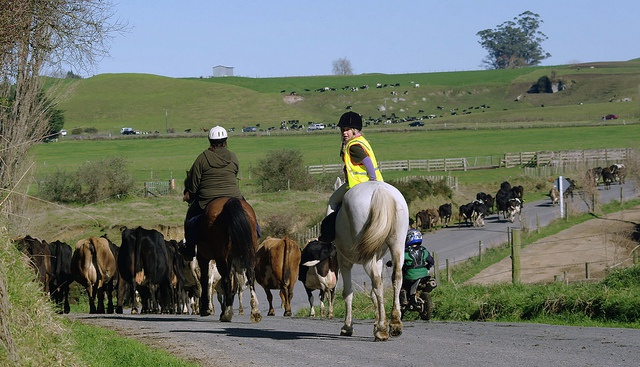Describe the objects in this image and their specific colors. I can see cow in black, gray, and darkgreen tones, horse in black, darkgray, lavender, and gray tones, horse in black, maroon, and gray tones, people in black, darkgreen, and gray tones, and cow in black, gray, and darkgreen tones in this image. 